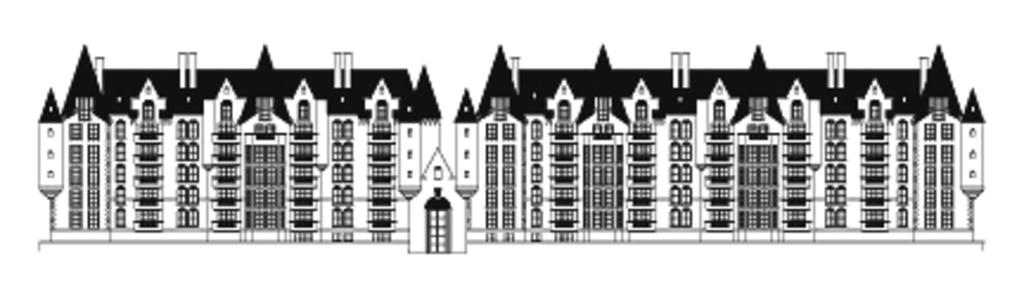What is the main subject of the image? The main subject of the image is a painting of a building. What flavor of ice cream is depicted in the painting of the building? There is no ice cream depicted in the painting of the building; it is a painting of a building. 